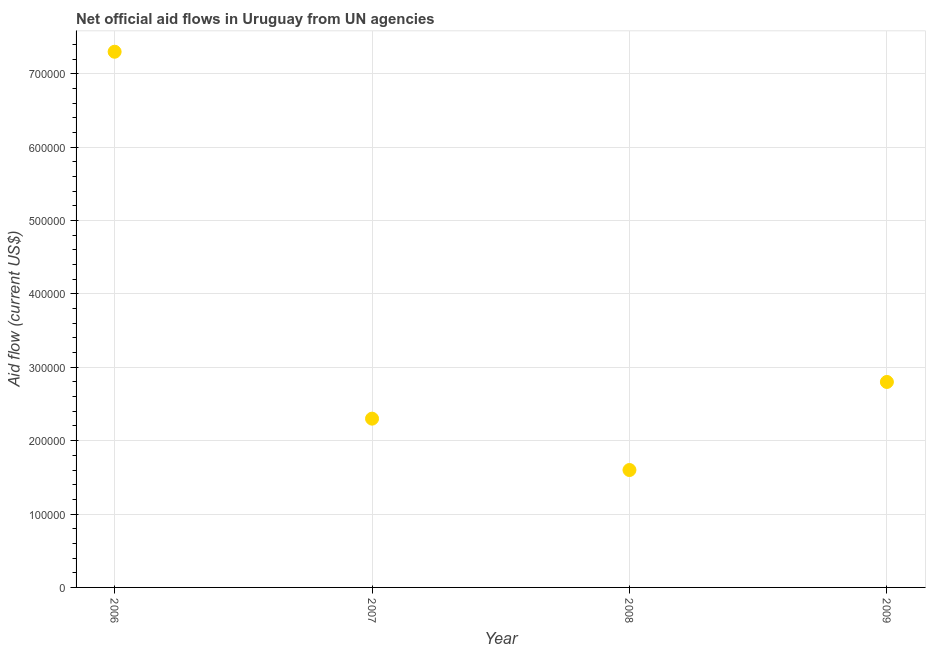What is the net official flows from un agencies in 2008?
Make the answer very short. 1.60e+05. Across all years, what is the maximum net official flows from un agencies?
Provide a succinct answer. 7.30e+05. Across all years, what is the minimum net official flows from un agencies?
Ensure brevity in your answer.  1.60e+05. In which year was the net official flows from un agencies maximum?
Ensure brevity in your answer.  2006. What is the sum of the net official flows from un agencies?
Make the answer very short. 1.40e+06. What is the difference between the net official flows from un agencies in 2008 and 2009?
Your answer should be very brief. -1.20e+05. What is the average net official flows from un agencies per year?
Keep it short and to the point. 3.50e+05. What is the median net official flows from un agencies?
Your response must be concise. 2.55e+05. Do a majority of the years between 2009 and 2007 (inclusive) have net official flows from un agencies greater than 220000 US$?
Your answer should be compact. No. What is the ratio of the net official flows from un agencies in 2006 to that in 2008?
Ensure brevity in your answer.  4.56. Is the net official flows from un agencies in 2006 less than that in 2009?
Give a very brief answer. No. Is the difference between the net official flows from un agencies in 2008 and 2009 greater than the difference between any two years?
Offer a terse response. No. Is the sum of the net official flows from un agencies in 2007 and 2009 greater than the maximum net official flows from un agencies across all years?
Provide a succinct answer. No. What is the difference between the highest and the lowest net official flows from un agencies?
Provide a succinct answer. 5.70e+05. In how many years, is the net official flows from un agencies greater than the average net official flows from un agencies taken over all years?
Your response must be concise. 1. Does the net official flows from un agencies monotonically increase over the years?
Ensure brevity in your answer.  No. How many dotlines are there?
Offer a very short reply. 1. How many years are there in the graph?
Your answer should be very brief. 4. Are the values on the major ticks of Y-axis written in scientific E-notation?
Your answer should be compact. No. Does the graph contain any zero values?
Provide a short and direct response. No. What is the title of the graph?
Provide a short and direct response. Net official aid flows in Uruguay from UN agencies. What is the label or title of the X-axis?
Ensure brevity in your answer.  Year. What is the label or title of the Y-axis?
Make the answer very short. Aid flow (current US$). What is the Aid flow (current US$) in 2006?
Provide a succinct answer. 7.30e+05. What is the Aid flow (current US$) in 2007?
Keep it short and to the point. 2.30e+05. What is the Aid flow (current US$) in 2008?
Make the answer very short. 1.60e+05. What is the Aid flow (current US$) in 2009?
Provide a short and direct response. 2.80e+05. What is the difference between the Aid flow (current US$) in 2006 and 2008?
Offer a terse response. 5.70e+05. What is the difference between the Aid flow (current US$) in 2006 and 2009?
Offer a very short reply. 4.50e+05. What is the difference between the Aid flow (current US$) in 2007 and 2008?
Keep it short and to the point. 7.00e+04. What is the difference between the Aid flow (current US$) in 2007 and 2009?
Keep it short and to the point. -5.00e+04. What is the ratio of the Aid flow (current US$) in 2006 to that in 2007?
Offer a terse response. 3.17. What is the ratio of the Aid flow (current US$) in 2006 to that in 2008?
Ensure brevity in your answer.  4.56. What is the ratio of the Aid flow (current US$) in 2006 to that in 2009?
Offer a terse response. 2.61. What is the ratio of the Aid flow (current US$) in 2007 to that in 2008?
Your response must be concise. 1.44. What is the ratio of the Aid flow (current US$) in 2007 to that in 2009?
Keep it short and to the point. 0.82. What is the ratio of the Aid flow (current US$) in 2008 to that in 2009?
Your answer should be compact. 0.57. 